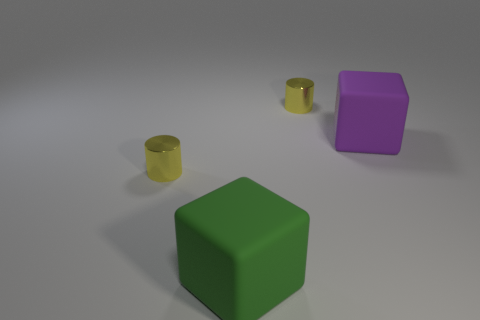What color is the other large thing that is made of the same material as the purple object?
Keep it short and to the point. Green. How many brown things are either cylinders or blocks?
Make the answer very short. 0. Are there more big green objects than tiny yellow metal objects?
Offer a very short reply. No. How many things are either large cubes that are to the right of the green thing or small yellow things that are behind the large purple object?
Keep it short and to the point. 2. There is another cube that is the same size as the green matte block; what is its color?
Make the answer very short. Purple. Is the material of the large purple object the same as the large green cube?
Your answer should be very brief. Yes. What is the material of the big purple block behind the rubber block that is in front of the big purple rubber block?
Your answer should be very brief. Rubber. Is the number of yellow things on the right side of the big purple matte block greater than the number of big purple rubber cubes?
Provide a succinct answer. No. What number of other objects are the same size as the purple rubber cube?
Provide a short and direct response. 1. What is the color of the object to the right of the small shiny cylinder on the right side of the small yellow shiny cylinder that is in front of the big purple rubber object?
Provide a short and direct response. Purple. 